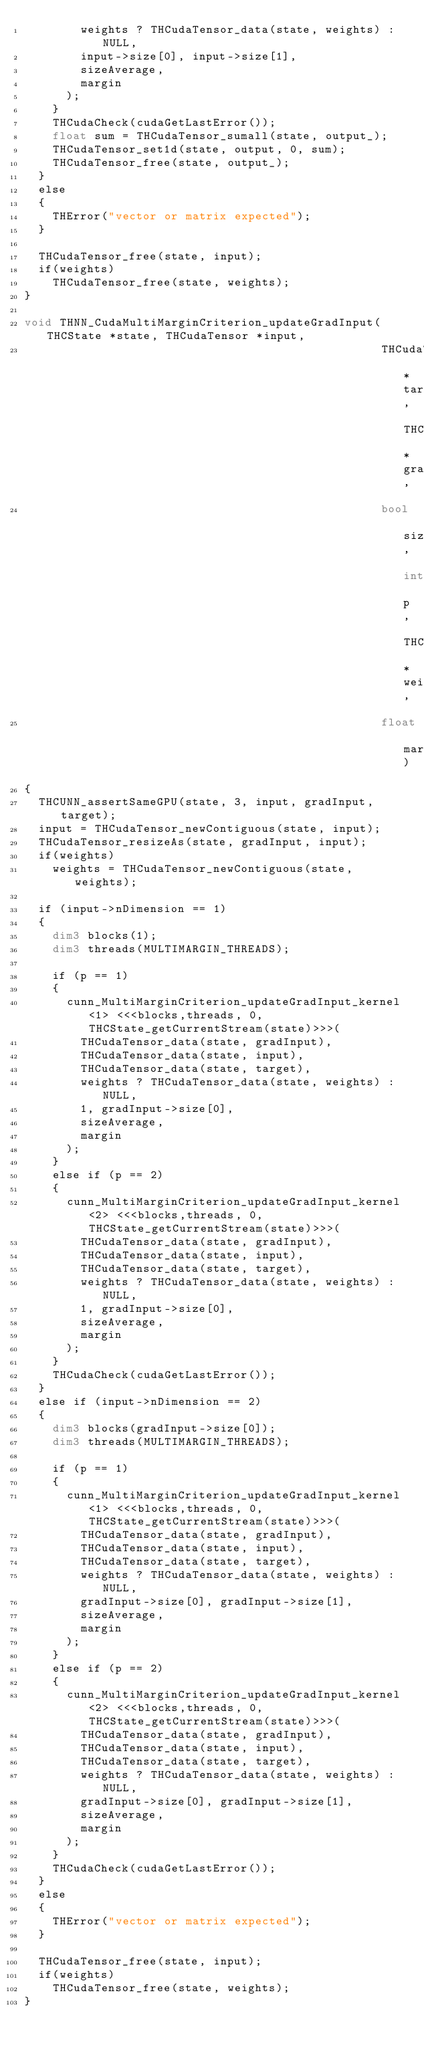<code> <loc_0><loc_0><loc_500><loc_500><_Cuda_>        weights ? THCudaTensor_data(state, weights) : NULL,
        input->size[0], input->size[1],
        sizeAverage,
        margin
      );
    }
    THCudaCheck(cudaGetLastError());
    float sum = THCudaTensor_sumall(state, output_);
    THCudaTensor_set1d(state, output, 0, sum);
    THCudaTensor_free(state, output_);
  }
  else
  {
    THError("vector or matrix expected");
  }

  THCudaTensor_free(state, input);
  if(weights)
    THCudaTensor_free(state, weights);
}

void THNN_CudaMultiMarginCriterion_updateGradInput(THCState *state, THCudaTensor *input,
                                                   THCudaTensor *target, THCudaTensor *gradInput,
                                                   bool sizeAverage, int p, THCudaTensor *weights,
                                                   float margin)
{
  THCUNN_assertSameGPU(state, 3, input, gradInput, target);
  input = THCudaTensor_newContiguous(state, input);
  THCudaTensor_resizeAs(state, gradInput, input);
  if(weights)
    weights = THCudaTensor_newContiguous(state, weights);

  if (input->nDimension == 1)
  {
    dim3 blocks(1);
    dim3 threads(MULTIMARGIN_THREADS);

    if (p == 1)
    {
      cunn_MultiMarginCriterion_updateGradInput_kernel<1> <<<blocks,threads, 0, THCState_getCurrentStream(state)>>>(
        THCudaTensor_data(state, gradInput),
        THCudaTensor_data(state, input),
        THCudaTensor_data(state, target),
        weights ? THCudaTensor_data(state, weights) : NULL,
        1, gradInput->size[0],
        sizeAverage,
        margin
      );
    }
    else if (p == 2)
    {
      cunn_MultiMarginCriterion_updateGradInput_kernel<2> <<<blocks,threads, 0, THCState_getCurrentStream(state)>>>(
        THCudaTensor_data(state, gradInput),
        THCudaTensor_data(state, input),
        THCudaTensor_data(state, target),
        weights ? THCudaTensor_data(state, weights) : NULL,
        1, gradInput->size[0],
        sizeAverage,
        margin
      );
    }
    THCudaCheck(cudaGetLastError());
  }
  else if (input->nDimension == 2)
  {
    dim3 blocks(gradInput->size[0]);
    dim3 threads(MULTIMARGIN_THREADS);

    if (p == 1)
    {
      cunn_MultiMarginCriterion_updateGradInput_kernel<1> <<<blocks,threads, 0, THCState_getCurrentStream(state)>>>(
        THCudaTensor_data(state, gradInput),
        THCudaTensor_data(state, input),
        THCudaTensor_data(state, target),
        weights ? THCudaTensor_data(state, weights) : NULL,
        gradInput->size[0], gradInput->size[1],
        sizeAverage,
        margin
      );
    }
    else if (p == 2)
    {
      cunn_MultiMarginCriterion_updateGradInput_kernel<2> <<<blocks,threads, 0, THCState_getCurrentStream(state)>>>(
        THCudaTensor_data(state, gradInput),
        THCudaTensor_data(state, input),
        THCudaTensor_data(state, target),
        weights ? THCudaTensor_data(state, weights) : NULL,
        gradInput->size[0], gradInput->size[1],
        sizeAverage,
        margin
      );
    }
    THCudaCheck(cudaGetLastError());
  }
  else
  {
    THError("vector or matrix expected");
  }

  THCudaTensor_free(state, input);
  if(weights)
    THCudaTensor_free(state, weights);
}
</code> 